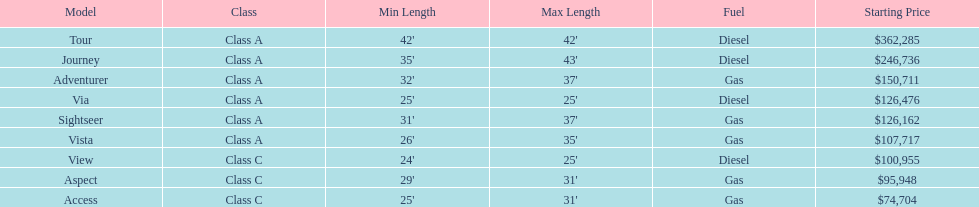Is the vista more than the aspect? Yes. 